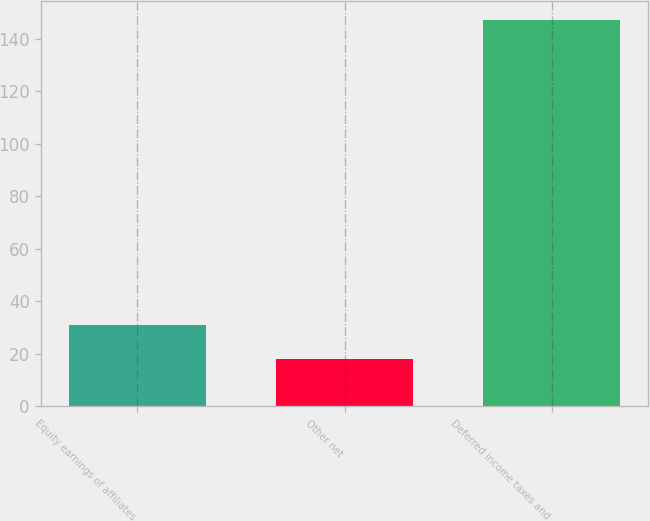Convert chart to OTSL. <chart><loc_0><loc_0><loc_500><loc_500><bar_chart><fcel>Equity earnings of affiliates<fcel>Other net<fcel>Deferred income taxes and<nl><fcel>30.9<fcel>18<fcel>147<nl></chart> 